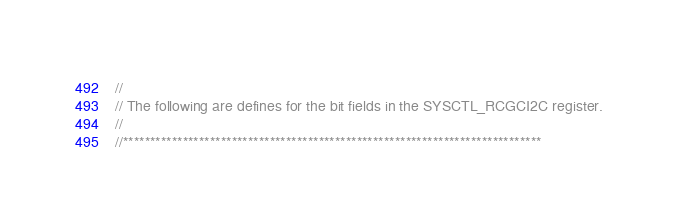Convert code to text. <code><loc_0><loc_0><loc_500><loc_500><_C_>//
// The following are defines for the bit fields in the SYSCTL_RCGCI2C register.
//
//*****************************************************************************</code> 